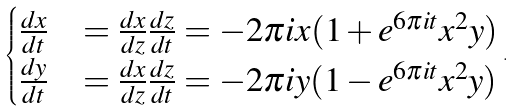Convert formula to latex. <formula><loc_0><loc_0><loc_500><loc_500>\begin{cases} \frac { d x } { d t } & = \frac { d x } { d z } \frac { d z } { d t } = - 2 \pi i x ( 1 + e ^ { 6 \pi i t } x ^ { 2 } y ) \\ \frac { d y } { d t } & = \frac { d x } { d z } \frac { d z } { d t } = - 2 \pi i y ( 1 - e ^ { 6 \pi i t } x ^ { 2 } y ) \end{cases} \, .</formula> 